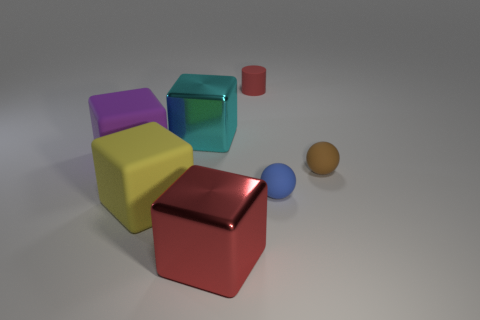Subtract 1 cubes. How many cubes are left? 3 Add 2 big cyan metal cubes. How many objects exist? 9 Subtract all cylinders. How many objects are left? 6 Add 2 blue metal balls. How many blue metal balls exist? 2 Subtract 0 blue cubes. How many objects are left? 7 Subtract all red metal blocks. Subtract all large purple cubes. How many objects are left? 5 Add 6 small red matte things. How many small red matte things are left? 7 